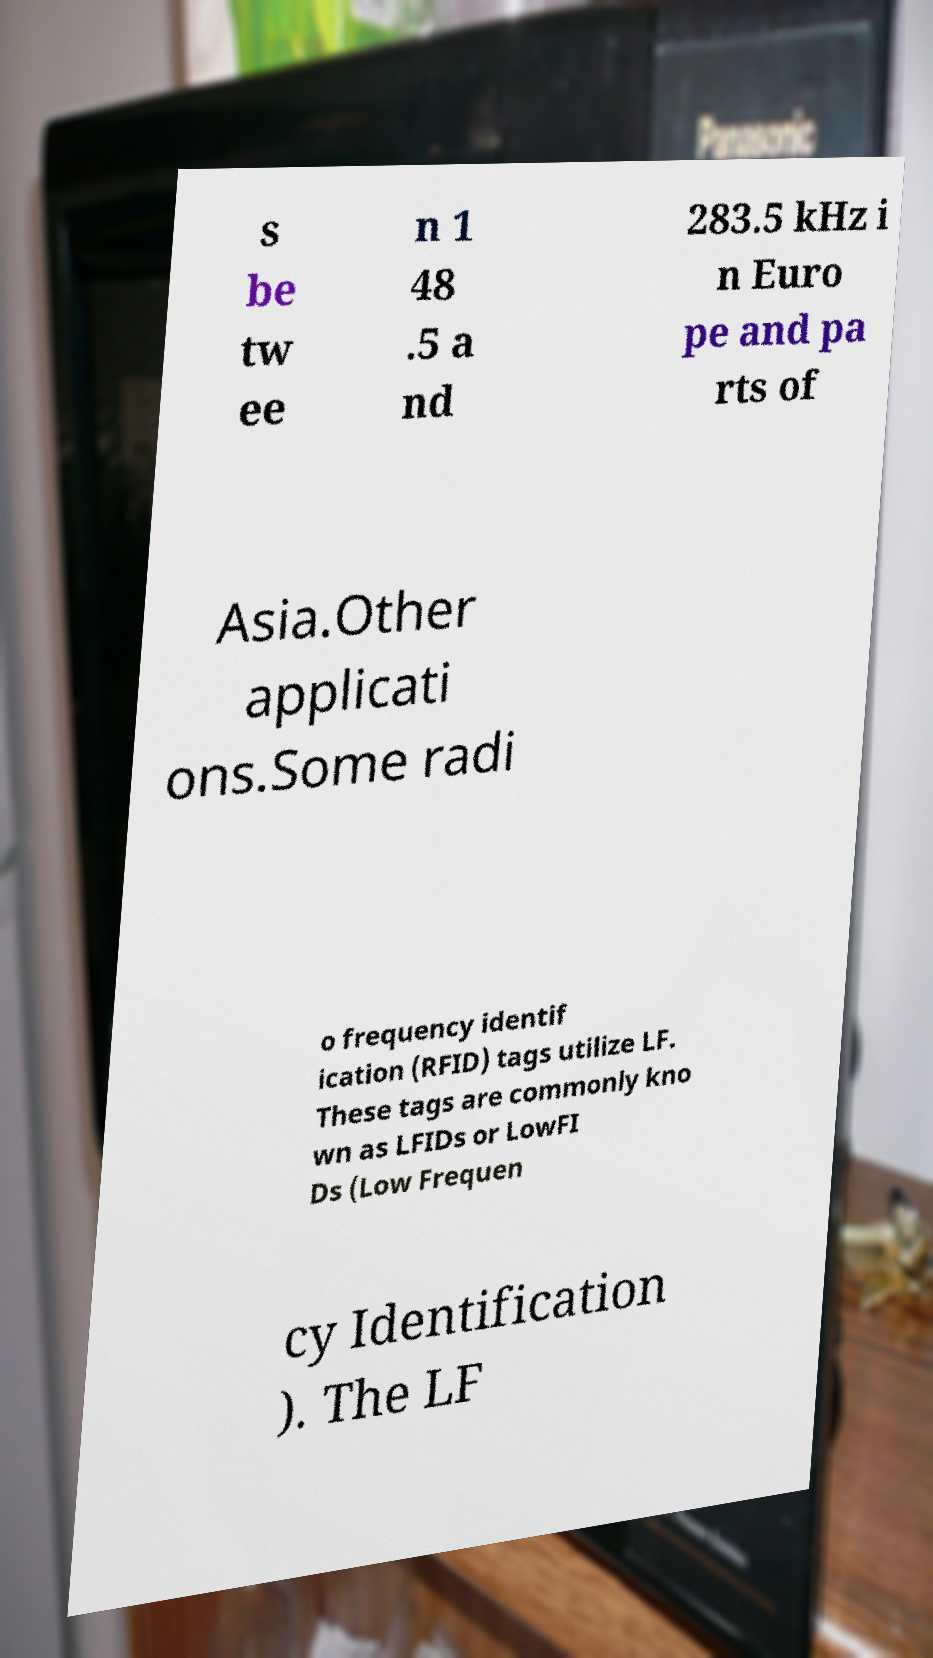There's text embedded in this image that I need extracted. Can you transcribe it verbatim? s be tw ee n 1 48 .5 a nd 283.5 kHz i n Euro pe and pa rts of Asia.Other applicati ons.Some radi o frequency identif ication (RFID) tags utilize LF. These tags are commonly kno wn as LFIDs or LowFI Ds (Low Frequen cy Identification ). The LF 